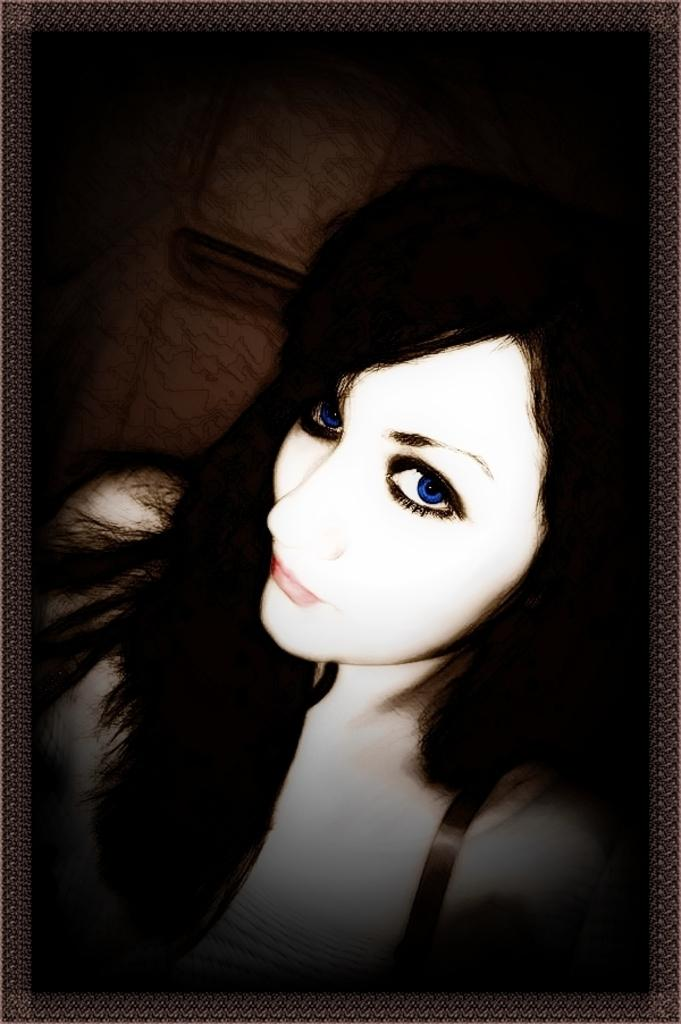Who is present in the image? There is a woman in the image. Can you describe anything in the background of the image? There is an object attached to the wall in the background of the image. What type of transport is depicted in the image? There is no transport visible in the image; it features a woman and an object on the wall. What shape is the war in the image? There is no war present in the image, and therefore no shape can be attributed to it. 